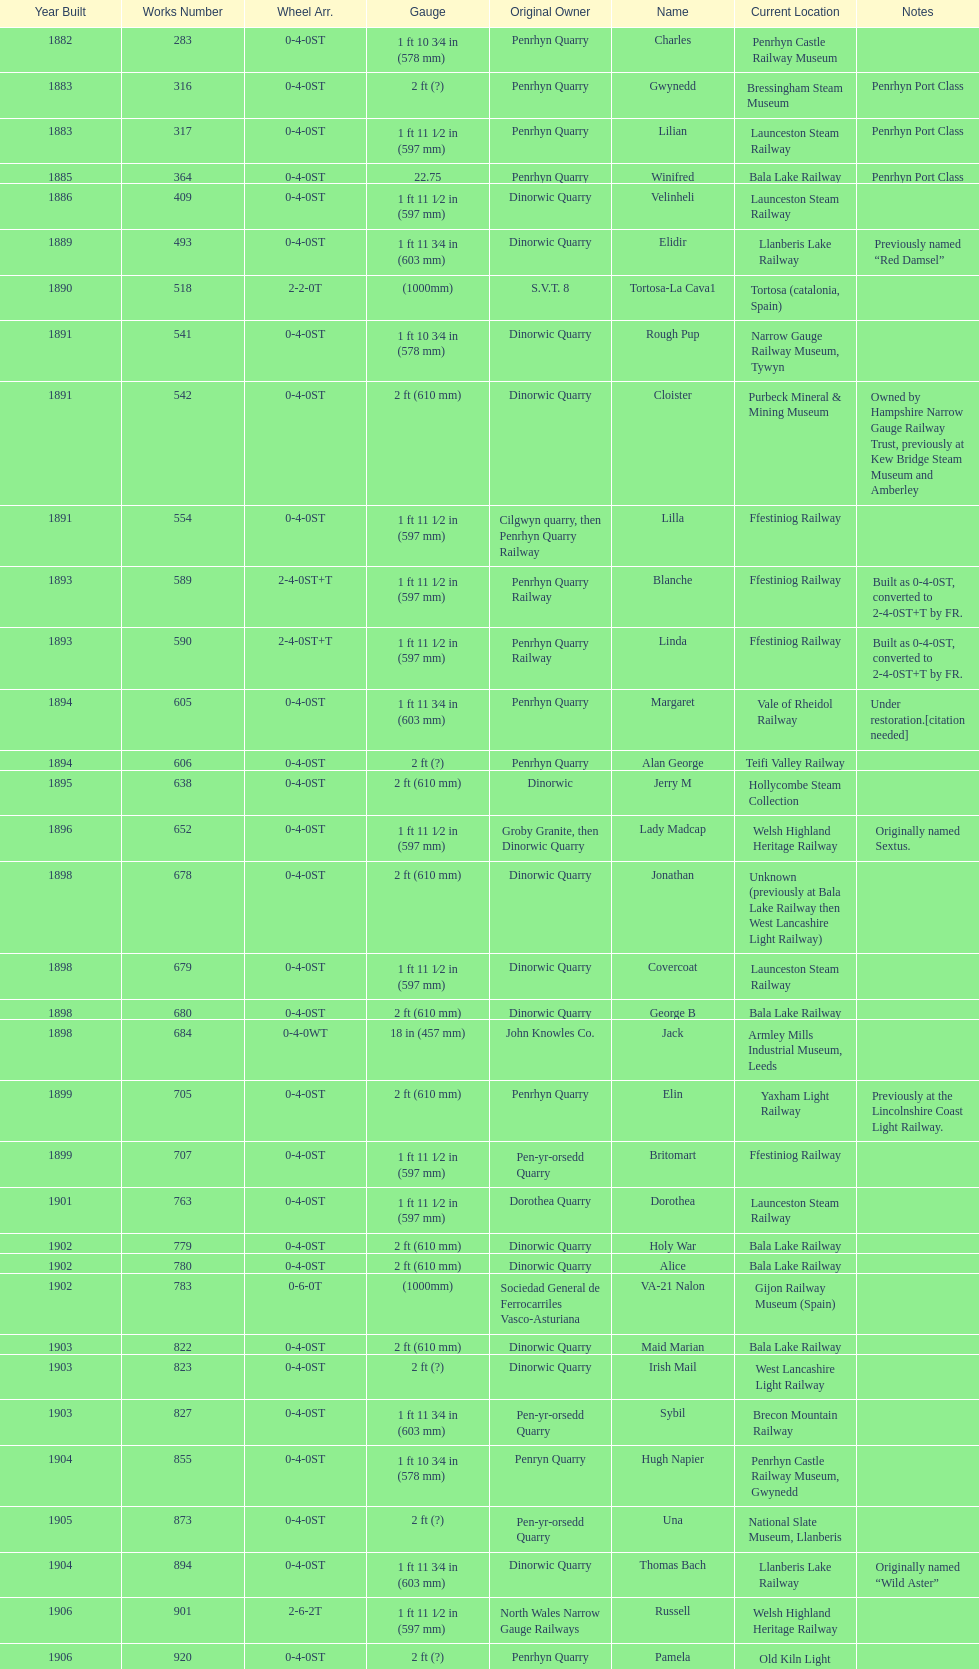What is the variation in gauge between works numbers 541 and 542? 32 mm. 